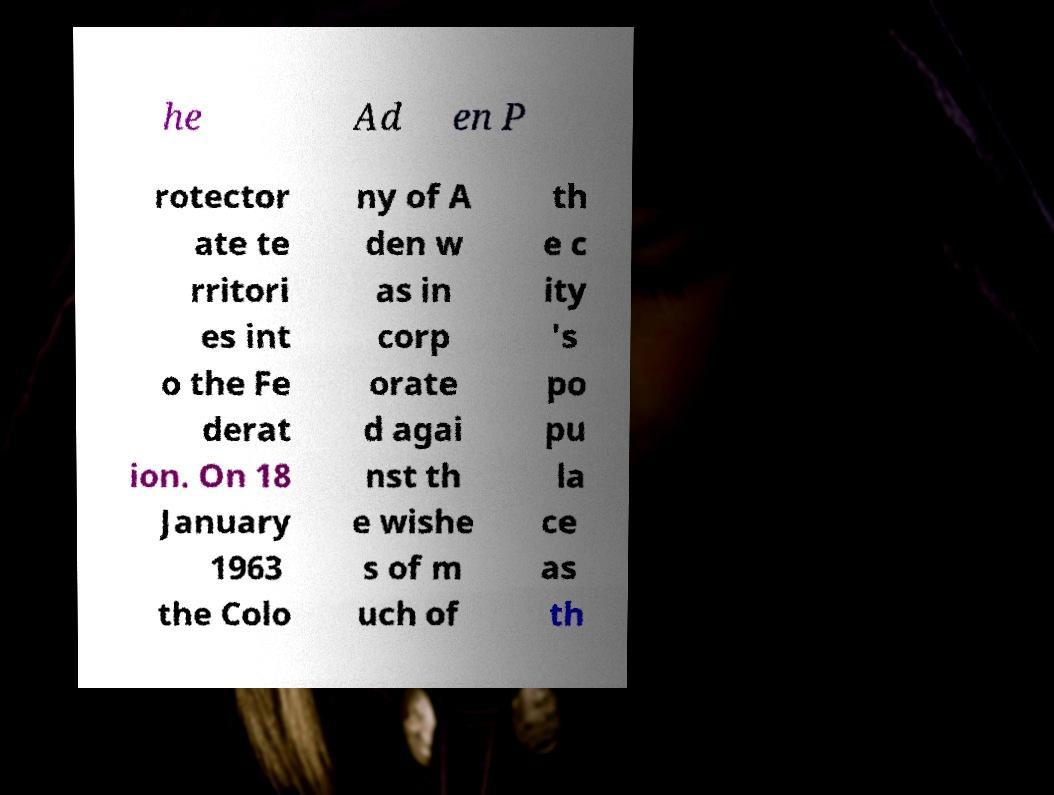For documentation purposes, I need the text within this image transcribed. Could you provide that? he Ad en P rotector ate te rritori es int o the Fe derat ion. On 18 January 1963 the Colo ny of A den w as in corp orate d agai nst th e wishe s of m uch of th e c ity 's po pu la ce as th 